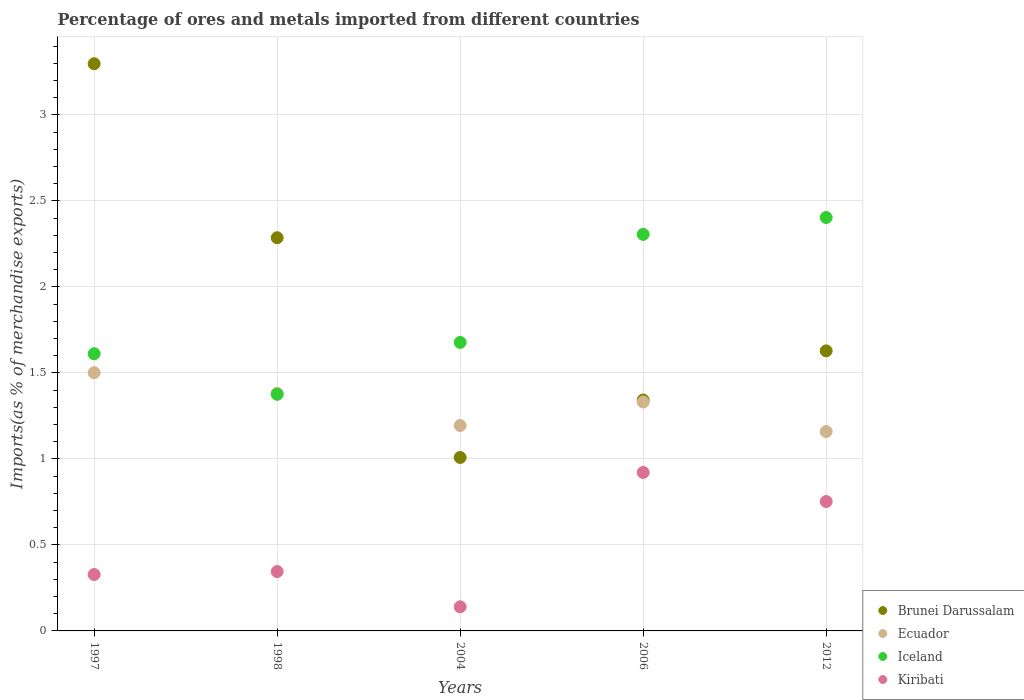How many different coloured dotlines are there?
Keep it short and to the point. 4. What is the percentage of imports to different countries in Brunei Darussalam in 2004?
Your answer should be very brief. 1.01. Across all years, what is the maximum percentage of imports to different countries in Ecuador?
Provide a short and direct response. 1.5. Across all years, what is the minimum percentage of imports to different countries in Kiribati?
Your answer should be very brief. 0.14. What is the total percentage of imports to different countries in Ecuador in the graph?
Ensure brevity in your answer.  6.57. What is the difference between the percentage of imports to different countries in Brunei Darussalam in 1997 and that in 2012?
Offer a terse response. 1.67. What is the difference between the percentage of imports to different countries in Iceland in 2004 and the percentage of imports to different countries in Kiribati in 2012?
Make the answer very short. 0.93. What is the average percentage of imports to different countries in Kiribati per year?
Keep it short and to the point. 0.5. In the year 1998, what is the difference between the percentage of imports to different countries in Ecuador and percentage of imports to different countries in Kiribati?
Provide a short and direct response. 1.04. What is the ratio of the percentage of imports to different countries in Ecuador in 2004 to that in 2012?
Your answer should be very brief. 1.03. What is the difference between the highest and the second highest percentage of imports to different countries in Iceland?
Your response must be concise. 0.1. What is the difference between the highest and the lowest percentage of imports to different countries in Brunei Darussalam?
Your answer should be compact. 2.29. In how many years, is the percentage of imports to different countries in Ecuador greater than the average percentage of imports to different countries in Ecuador taken over all years?
Your answer should be compact. 3. Is it the case that in every year, the sum of the percentage of imports to different countries in Kiribati and percentage of imports to different countries in Ecuador  is greater than the sum of percentage of imports to different countries in Iceland and percentage of imports to different countries in Brunei Darussalam?
Your answer should be compact. Yes. How many dotlines are there?
Provide a short and direct response. 4. Does the graph contain any zero values?
Give a very brief answer. No. Does the graph contain grids?
Keep it short and to the point. Yes. Where does the legend appear in the graph?
Make the answer very short. Bottom right. How many legend labels are there?
Ensure brevity in your answer.  4. How are the legend labels stacked?
Your response must be concise. Vertical. What is the title of the graph?
Provide a short and direct response. Percentage of ores and metals imported from different countries. What is the label or title of the X-axis?
Your answer should be very brief. Years. What is the label or title of the Y-axis?
Offer a terse response. Imports(as % of merchandise exports). What is the Imports(as % of merchandise exports) in Brunei Darussalam in 1997?
Provide a short and direct response. 3.3. What is the Imports(as % of merchandise exports) in Ecuador in 1997?
Offer a terse response. 1.5. What is the Imports(as % of merchandise exports) of Iceland in 1997?
Give a very brief answer. 1.61. What is the Imports(as % of merchandise exports) in Kiribati in 1997?
Ensure brevity in your answer.  0.33. What is the Imports(as % of merchandise exports) of Brunei Darussalam in 1998?
Your response must be concise. 2.29. What is the Imports(as % of merchandise exports) of Ecuador in 1998?
Keep it short and to the point. 1.38. What is the Imports(as % of merchandise exports) in Iceland in 1998?
Your answer should be compact. 1.38. What is the Imports(as % of merchandise exports) of Kiribati in 1998?
Your answer should be compact. 0.35. What is the Imports(as % of merchandise exports) of Brunei Darussalam in 2004?
Make the answer very short. 1.01. What is the Imports(as % of merchandise exports) in Ecuador in 2004?
Offer a very short reply. 1.19. What is the Imports(as % of merchandise exports) in Iceland in 2004?
Ensure brevity in your answer.  1.68. What is the Imports(as % of merchandise exports) in Kiribati in 2004?
Provide a succinct answer. 0.14. What is the Imports(as % of merchandise exports) in Brunei Darussalam in 2006?
Keep it short and to the point. 1.34. What is the Imports(as % of merchandise exports) of Ecuador in 2006?
Your answer should be very brief. 1.33. What is the Imports(as % of merchandise exports) in Iceland in 2006?
Your response must be concise. 2.31. What is the Imports(as % of merchandise exports) of Kiribati in 2006?
Give a very brief answer. 0.92. What is the Imports(as % of merchandise exports) of Brunei Darussalam in 2012?
Make the answer very short. 1.63. What is the Imports(as % of merchandise exports) of Ecuador in 2012?
Your answer should be very brief. 1.16. What is the Imports(as % of merchandise exports) in Iceland in 2012?
Your answer should be very brief. 2.4. What is the Imports(as % of merchandise exports) in Kiribati in 2012?
Ensure brevity in your answer.  0.75. Across all years, what is the maximum Imports(as % of merchandise exports) of Brunei Darussalam?
Provide a short and direct response. 3.3. Across all years, what is the maximum Imports(as % of merchandise exports) of Ecuador?
Your answer should be compact. 1.5. Across all years, what is the maximum Imports(as % of merchandise exports) of Iceland?
Offer a terse response. 2.4. Across all years, what is the maximum Imports(as % of merchandise exports) of Kiribati?
Offer a very short reply. 0.92. Across all years, what is the minimum Imports(as % of merchandise exports) of Brunei Darussalam?
Keep it short and to the point. 1.01. Across all years, what is the minimum Imports(as % of merchandise exports) in Ecuador?
Your answer should be very brief. 1.16. Across all years, what is the minimum Imports(as % of merchandise exports) of Iceland?
Make the answer very short. 1.38. Across all years, what is the minimum Imports(as % of merchandise exports) in Kiribati?
Make the answer very short. 0.14. What is the total Imports(as % of merchandise exports) in Brunei Darussalam in the graph?
Your answer should be compact. 9.56. What is the total Imports(as % of merchandise exports) in Ecuador in the graph?
Give a very brief answer. 6.57. What is the total Imports(as % of merchandise exports) of Iceland in the graph?
Your answer should be very brief. 9.37. What is the total Imports(as % of merchandise exports) in Kiribati in the graph?
Make the answer very short. 2.49. What is the difference between the Imports(as % of merchandise exports) in Brunei Darussalam in 1997 and that in 1998?
Your answer should be very brief. 1.01. What is the difference between the Imports(as % of merchandise exports) in Ecuador in 1997 and that in 1998?
Your answer should be very brief. 0.12. What is the difference between the Imports(as % of merchandise exports) of Iceland in 1997 and that in 1998?
Ensure brevity in your answer.  0.24. What is the difference between the Imports(as % of merchandise exports) of Kiribati in 1997 and that in 1998?
Give a very brief answer. -0.02. What is the difference between the Imports(as % of merchandise exports) in Brunei Darussalam in 1997 and that in 2004?
Keep it short and to the point. 2.29. What is the difference between the Imports(as % of merchandise exports) in Ecuador in 1997 and that in 2004?
Make the answer very short. 0.31. What is the difference between the Imports(as % of merchandise exports) in Iceland in 1997 and that in 2004?
Your answer should be very brief. -0.07. What is the difference between the Imports(as % of merchandise exports) of Kiribati in 1997 and that in 2004?
Give a very brief answer. 0.19. What is the difference between the Imports(as % of merchandise exports) in Brunei Darussalam in 1997 and that in 2006?
Your response must be concise. 1.96. What is the difference between the Imports(as % of merchandise exports) in Ecuador in 1997 and that in 2006?
Offer a terse response. 0.17. What is the difference between the Imports(as % of merchandise exports) in Iceland in 1997 and that in 2006?
Your response must be concise. -0.69. What is the difference between the Imports(as % of merchandise exports) in Kiribati in 1997 and that in 2006?
Make the answer very short. -0.59. What is the difference between the Imports(as % of merchandise exports) of Brunei Darussalam in 1997 and that in 2012?
Keep it short and to the point. 1.67. What is the difference between the Imports(as % of merchandise exports) in Ecuador in 1997 and that in 2012?
Offer a very short reply. 0.34. What is the difference between the Imports(as % of merchandise exports) of Iceland in 1997 and that in 2012?
Your answer should be very brief. -0.79. What is the difference between the Imports(as % of merchandise exports) of Kiribati in 1997 and that in 2012?
Your answer should be compact. -0.42. What is the difference between the Imports(as % of merchandise exports) of Brunei Darussalam in 1998 and that in 2004?
Provide a short and direct response. 1.28. What is the difference between the Imports(as % of merchandise exports) of Ecuador in 1998 and that in 2004?
Make the answer very short. 0.19. What is the difference between the Imports(as % of merchandise exports) in Iceland in 1998 and that in 2004?
Ensure brevity in your answer.  -0.3. What is the difference between the Imports(as % of merchandise exports) in Kiribati in 1998 and that in 2004?
Provide a succinct answer. 0.2. What is the difference between the Imports(as % of merchandise exports) of Brunei Darussalam in 1998 and that in 2006?
Your response must be concise. 0.94. What is the difference between the Imports(as % of merchandise exports) in Ecuador in 1998 and that in 2006?
Ensure brevity in your answer.  0.05. What is the difference between the Imports(as % of merchandise exports) of Iceland in 1998 and that in 2006?
Keep it short and to the point. -0.93. What is the difference between the Imports(as % of merchandise exports) of Kiribati in 1998 and that in 2006?
Give a very brief answer. -0.58. What is the difference between the Imports(as % of merchandise exports) in Brunei Darussalam in 1998 and that in 2012?
Provide a short and direct response. 0.66. What is the difference between the Imports(as % of merchandise exports) of Ecuador in 1998 and that in 2012?
Ensure brevity in your answer.  0.22. What is the difference between the Imports(as % of merchandise exports) of Iceland in 1998 and that in 2012?
Keep it short and to the point. -1.03. What is the difference between the Imports(as % of merchandise exports) in Kiribati in 1998 and that in 2012?
Provide a short and direct response. -0.41. What is the difference between the Imports(as % of merchandise exports) of Brunei Darussalam in 2004 and that in 2006?
Your answer should be compact. -0.33. What is the difference between the Imports(as % of merchandise exports) in Ecuador in 2004 and that in 2006?
Keep it short and to the point. -0.14. What is the difference between the Imports(as % of merchandise exports) of Iceland in 2004 and that in 2006?
Provide a succinct answer. -0.63. What is the difference between the Imports(as % of merchandise exports) of Kiribati in 2004 and that in 2006?
Keep it short and to the point. -0.78. What is the difference between the Imports(as % of merchandise exports) of Brunei Darussalam in 2004 and that in 2012?
Keep it short and to the point. -0.62. What is the difference between the Imports(as % of merchandise exports) of Ecuador in 2004 and that in 2012?
Offer a terse response. 0.03. What is the difference between the Imports(as % of merchandise exports) in Iceland in 2004 and that in 2012?
Offer a very short reply. -0.73. What is the difference between the Imports(as % of merchandise exports) of Kiribati in 2004 and that in 2012?
Offer a very short reply. -0.61. What is the difference between the Imports(as % of merchandise exports) of Brunei Darussalam in 2006 and that in 2012?
Make the answer very short. -0.29. What is the difference between the Imports(as % of merchandise exports) in Ecuador in 2006 and that in 2012?
Your response must be concise. 0.17. What is the difference between the Imports(as % of merchandise exports) of Iceland in 2006 and that in 2012?
Make the answer very short. -0.1. What is the difference between the Imports(as % of merchandise exports) of Kiribati in 2006 and that in 2012?
Offer a terse response. 0.17. What is the difference between the Imports(as % of merchandise exports) in Brunei Darussalam in 1997 and the Imports(as % of merchandise exports) in Ecuador in 1998?
Make the answer very short. 1.92. What is the difference between the Imports(as % of merchandise exports) in Brunei Darussalam in 1997 and the Imports(as % of merchandise exports) in Iceland in 1998?
Offer a very short reply. 1.92. What is the difference between the Imports(as % of merchandise exports) in Brunei Darussalam in 1997 and the Imports(as % of merchandise exports) in Kiribati in 1998?
Ensure brevity in your answer.  2.95. What is the difference between the Imports(as % of merchandise exports) of Ecuador in 1997 and the Imports(as % of merchandise exports) of Iceland in 1998?
Give a very brief answer. 0.13. What is the difference between the Imports(as % of merchandise exports) of Ecuador in 1997 and the Imports(as % of merchandise exports) of Kiribati in 1998?
Your answer should be compact. 1.16. What is the difference between the Imports(as % of merchandise exports) of Iceland in 1997 and the Imports(as % of merchandise exports) of Kiribati in 1998?
Provide a succinct answer. 1.27. What is the difference between the Imports(as % of merchandise exports) of Brunei Darussalam in 1997 and the Imports(as % of merchandise exports) of Ecuador in 2004?
Make the answer very short. 2.1. What is the difference between the Imports(as % of merchandise exports) of Brunei Darussalam in 1997 and the Imports(as % of merchandise exports) of Iceland in 2004?
Ensure brevity in your answer.  1.62. What is the difference between the Imports(as % of merchandise exports) of Brunei Darussalam in 1997 and the Imports(as % of merchandise exports) of Kiribati in 2004?
Make the answer very short. 3.16. What is the difference between the Imports(as % of merchandise exports) of Ecuador in 1997 and the Imports(as % of merchandise exports) of Iceland in 2004?
Make the answer very short. -0.18. What is the difference between the Imports(as % of merchandise exports) of Ecuador in 1997 and the Imports(as % of merchandise exports) of Kiribati in 2004?
Your response must be concise. 1.36. What is the difference between the Imports(as % of merchandise exports) in Iceland in 1997 and the Imports(as % of merchandise exports) in Kiribati in 2004?
Keep it short and to the point. 1.47. What is the difference between the Imports(as % of merchandise exports) in Brunei Darussalam in 1997 and the Imports(as % of merchandise exports) in Ecuador in 2006?
Ensure brevity in your answer.  1.97. What is the difference between the Imports(as % of merchandise exports) of Brunei Darussalam in 1997 and the Imports(as % of merchandise exports) of Iceland in 2006?
Provide a short and direct response. 0.99. What is the difference between the Imports(as % of merchandise exports) in Brunei Darussalam in 1997 and the Imports(as % of merchandise exports) in Kiribati in 2006?
Offer a terse response. 2.38. What is the difference between the Imports(as % of merchandise exports) in Ecuador in 1997 and the Imports(as % of merchandise exports) in Iceland in 2006?
Your answer should be very brief. -0.8. What is the difference between the Imports(as % of merchandise exports) of Ecuador in 1997 and the Imports(as % of merchandise exports) of Kiribati in 2006?
Provide a short and direct response. 0.58. What is the difference between the Imports(as % of merchandise exports) of Iceland in 1997 and the Imports(as % of merchandise exports) of Kiribati in 2006?
Provide a short and direct response. 0.69. What is the difference between the Imports(as % of merchandise exports) of Brunei Darussalam in 1997 and the Imports(as % of merchandise exports) of Ecuador in 2012?
Offer a terse response. 2.14. What is the difference between the Imports(as % of merchandise exports) in Brunei Darussalam in 1997 and the Imports(as % of merchandise exports) in Iceland in 2012?
Provide a short and direct response. 0.89. What is the difference between the Imports(as % of merchandise exports) of Brunei Darussalam in 1997 and the Imports(as % of merchandise exports) of Kiribati in 2012?
Offer a terse response. 2.55. What is the difference between the Imports(as % of merchandise exports) of Ecuador in 1997 and the Imports(as % of merchandise exports) of Iceland in 2012?
Keep it short and to the point. -0.9. What is the difference between the Imports(as % of merchandise exports) of Ecuador in 1997 and the Imports(as % of merchandise exports) of Kiribati in 2012?
Ensure brevity in your answer.  0.75. What is the difference between the Imports(as % of merchandise exports) of Iceland in 1997 and the Imports(as % of merchandise exports) of Kiribati in 2012?
Provide a short and direct response. 0.86. What is the difference between the Imports(as % of merchandise exports) in Brunei Darussalam in 1998 and the Imports(as % of merchandise exports) in Ecuador in 2004?
Your answer should be very brief. 1.09. What is the difference between the Imports(as % of merchandise exports) in Brunei Darussalam in 1998 and the Imports(as % of merchandise exports) in Iceland in 2004?
Give a very brief answer. 0.61. What is the difference between the Imports(as % of merchandise exports) in Brunei Darussalam in 1998 and the Imports(as % of merchandise exports) in Kiribati in 2004?
Provide a succinct answer. 2.15. What is the difference between the Imports(as % of merchandise exports) of Ecuador in 1998 and the Imports(as % of merchandise exports) of Iceland in 2004?
Your answer should be very brief. -0.3. What is the difference between the Imports(as % of merchandise exports) of Ecuador in 1998 and the Imports(as % of merchandise exports) of Kiribati in 2004?
Give a very brief answer. 1.24. What is the difference between the Imports(as % of merchandise exports) of Iceland in 1998 and the Imports(as % of merchandise exports) of Kiribati in 2004?
Your answer should be compact. 1.24. What is the difference between the Imports(as % of merchandise exports) of Brunei Darussalam in 1998 and the Imports(as % of merchandise exports) of Ecuador in 2006?
Your answer should be compact. 0.96. What is the difference between the Imports(as % of merchandise exports) of Brunei Darussalam in 1998 and the Imports(as % of merchandise exports) of Iceland in 2006?
Keep it short and to the point. -0.02. What is the difference between the Imports(as % of merchandise exports) of Brunei Darussalam in 1998 and the Imports(as % of merchandise exports) of Kiribati in 2006?
Give a very brief answer. 1.36. What is the difference between the Imports(as % of merchandise exports) in Ecuador in 1998 and the Imports(as % of merchandise exports) in Iceland in 2006?
Provide a short and direct response. -0.92. What is the difference between the Imports(as % of merchandise exports) of Ecuador in 1998 and the Imports(as % of merchandise exports) of Kiribati in 2006?
Offer a terse response. 0.46. What is the difference between the Imports(as % of merchandise exports) in Iceland in 1998 and the Imports(as % of merchandise exports) in Kiribati in 2006?
Keep it short and to the point. 0.45. What is the difference between the Imports(as % of merchandise exports) of Brunei Darussalam in 1998 and the Imports(as % of merchandise exports) of Ecuador in 2012?
Ensure brevity in your answer.  1.13. What is the difference between the Imports(as % of merchandise exports) of Brunei Darussalam in 1998 and the Imports(as % of merchandise exports) of Iceland in 2012?
Provide a short and direct response. -0.12. What is the difference between the Imports(as % of merchandise exports) of Brunei Darussalam in 1998 and the Imports(as % of merchandise exports) of Kiribati in 2012?
Your answer should be compact. 1.53. What is the difference between the Imports(as % of merchandise exports) of Ecuador in 1998 and the Imports(as % of merchandise exports) of Iceland in 2012?
Make the answer very short. -1.02. What is the difference between the Imports(as % of merchandise exports) in Ecuador in 1998 and the Imports(as % of merchandise exports) in Kiribati in 2012?
Your answer should be compact. 0.63. What is the difference between the Imports(as % of merchandise exports) in Iceland in 1998 and the Imports(as % of merchandise exports) in Kiribati in 2012?
Ensure brevity in your answer.  0.62. What is the difference between the Imports(as % of merchandise exports) in Brunei Darussalam in 2004 and the Imports(as % of merchandise exports) in Ecuador in 2006?
Keep it short and to the point. -0.32. What is the difference between the Imports(as % of merchandise exports) in Brunei Darussalam in 2004 and the Imports(as % of merchandise exports) in Iceland in 2006?
Offer a terse response. -1.3. What is the difference between the Imports(as % of merchandise exports) in Brunei Darussalam in 2004 and the Imports(as % of merchandise exports) in Kiribati in 2006?
Keep it short and to the point. 0.09. What is the difference between the Imports(as % of merchandise exports) in Ecuador in 2004 and the Imports(as % of merchandise exports) in Iceland in 2006?
Provide a short and direct response. -1.11. What is the difference between the Imports(as % of merchandise exports) in Ecuador in 2004 and the Imports(as % of merchandise exports) in Kiribati in 2006?
Make the answer very short. 0.27. What is the difference between the Imports(as % of merchandise exports) of Iceland in 2004 and the Imports(as % of merchandise exports) of Kiribati in 2006?
Give a very brief answer. 0.76. What is the difference between the Imports(as % of merchandise exports) in Brunei Darussalam in 2004 and the Imports(as % of merchandise exports) in Ecuador in 2012?
Your response must be concise. -0.15. What is the difference between the Imports(as % of merchandise exports) of Brunei Darussalam in 2004 and the Imports(as % of merchandise exports) of Iceland in 2012?
Provide a short and direct response. -1.4. What is the difference between the Imports(as % of merchandise exports) of Brunei Darussalam in 2004 and the Imports(as % of merchandise exports) of Kiribati in 2012?
Provide a succinct answer. 0.26. What is the difference between the Imports(as % of merchandise exports) of Ecuador in 2004 and the Imports(as % of merchandise exports) of Iceland in 2012?
Your answer should be compact. -1.21. What is the difference between the Imports(as % of merchandise exports) of Ecuador in 2004 and the Imports(as % of merchandise exports) of Kiribati in 2012?
Your response must be concise. 0.44. What is the difference between the Imports(as % of merchandise exports) in Iceland in 2004 and the Imports(as % of merchandise exports) in Kiribati in 2012?
Provide a succinct answer. 0.93. What is the difference between the Imports(as % of merchandise exports) of Brunei Darussalam in 2006 and the Imports(as % of merchandise exports) of Ecuador in 2012?
Ensure brevity in your answer.  0.18. What is the difference between the Imports(as % of merchandise exports) in Brunei Darussalam in 2006 and the Imports(as % of merchandise exports) in Iceland in 2012?
Your answer should be compact. -1.06. What is the difference between the Imports(as % of merchandise exports) in Brunei Darussalam in 2006 and the Imports(as % of merchandise exports) in Kiribati in 2012?
Your answer should be very brief. 0.59. What is the difference between the Imports(as % of merchandise exports) of Ecuador in 2006 and the Imports(as % of merchandise exports) of Iceland in 2012?
Your answer should be compact. -1.07. What is the difference between the Imports(as % of merchandise exports) in Ecuador in 2006 and the Imports(as % of merchandise exports) in Kiribati in 2012?
Give a very brief answer. 0.58. What is the difference between the Imports(as % of merchandise exports) of Iceland in 2006 and the Imports(as % of merchandise exports) of Kiribati in 2012?
Make the answer very short. 1.55. What is the average Imports(as % of merchandise exports) in Brunei Darussalam per year?
Offer a very short reply. 1.91. What is the average Imports(as % of merchandise exports) of Ecuador per year?
Provide a succinct answer. 1.31. What is the average Imports(as % of merchandise exports) in Iceland per year?
Offer a terse response. 1.87. What is the average Imports(as % of merchandise exports) in Kiribati per year?
Make the answer very short. 0.5. In the year 1997, what is the difference between the Imports(as % of merchandise exports) of Brunei Darussalam and Imports(as % of merchandise exports) of Ecuador?
Provide a short and direct response. 1.8. In the year 1997, what is the difference between the Imports(as % of merchandise exports) in Brunei Darussalam and Imports(as % of merchandise exports) in Iceland?
Make the answer very short. 1.69. In the year 1997, what is the difference between the Imports(as % of merchandise exports) of Brunei Darussalam and Imports(as % of merchandise exports) of Kiribati?
Ensure brevity in your answer.  2.97. In the year 1997, what is the difference between the Imports(as % of merchandise exports) of Ecuador and Imports(as % of merchandise exports) of Iceland?
Provide a short and direct response. -0.11. In the year 1997, what is the difference between the Imports(as % of merchandise exports) of Ecuador and Imports(as % of merchandise exports) of Kiribati?
Ensure brevity in your answer.  1.17. In the year 1997, what is the difference between the Imports(as % of merchandise exports) in Iceland and Imports(as % of merchandise exports) in Kiribati?
Provide a short and direct response. 1.28. In the year 1998, what is the difference between the Imports(as % of merchandise exports) in Brunei Darussalam and Imports(as % of merchandise exports) in Ecuador?
Provide a short and direct response. 0.9. In the year 1998, what is the difference between the Imports(as % of merchandise exports) of Brunei Darussalam and Imports(as % of merchandise exports) of Iceland?
Your answer should be compact. 0.91. In the year 1998, what is the difference between the Imports(as % of merchandise exports) in Brunei Darussalam and Imports(as % of merchandise exports) in Kiribati?
Keep it short and to the point. 1.94. In the year 1998, what is the difference between the Imports(as % of merchandise exports) in Ecuador and Imports(as % of merchandise exports) in Iceland?
Provide a short and direct response. 0.01. In the year 1998, what is the difference between the Imports(as % of merchandise exports) in Ecuador and Imports(as % of merchandise exports) in Kiribati?
Provide a short and direct response. 1.04. In the year 1998, what is the difference between the Imports(as % of merchandise exports) in Iceland and Imports(as % of merchandise exports) in Kiribati?
Ensure brevity in your answer.  1.03. In the year 2004, what is the difference between the Imports(as % of merchandise exports) in Brunei Darussalam and Imports(as % of merchandise exports) in Ecuador?
Provide a short and direct response. -0.19. In the year 2004, what is the difference between the Imports(as % of merchandise exports) in Brunei Darussalam and Imports(as % of merchandise exports) in Iceland?
Keep it short and to the point. -0.67. In the year 2004, what is the difference between the Imports(as % of merchandise exports) in Brunei Darussalam and Imports(as % of merchandise exports) in Kiribati?
Your response must be concise. 0.87. In the year 2004, what is the difference between the Imports(as % of merchandise exports) of Ecuador and Imports(as % of merchandise exports) of Iceland?
Keep it short and to the point. -0.48. In the year 2004, what is the difference between the Imports(as % of merchandise exports) of Ecuador and Imports(as % of merchandise exports) of Kiribati?
Your answer should be very brief. 1.05. In the year 2004, what is the difference between the Imports(as % of merchandise exports) in Iceland and Imports(as % of merchandise exports) in Kiribati?
Your response must be concise. 1.54. In the year 2006, what is the difference between the Imports(as % of merchandise exports) in Brunei Darussalam and Imports(as % of merchandise exports) in Ecuador?
Provide a short and direct response. 0.01. In the year 2006, what is the difference between the Imports(as % of merchandise exports) in Brunei Darussalam and Imports(as % of merchandise exports) in Iceland?
Give a very brief answer. -0.96. In the year 2006, what is the difference between the Imports(as % of merchandise exports) of Brunei Darussalam and Imports(as % of merchandise exports) of Kiribati?
Ensure brevity in your answer.  0.42. In the year 2006, what is the difference between the Imports(as % of merchandise exports) of Ecuador and Imports(as % of merchandise exports) of Iceland?
Offer a terse response. -0.97. In the year 2006, what is the difference between the Imports(as % of merchandise exports) of Ecuador and Imports(as % of merchandise exports) of Kiribati?
Offer a terse response. 0.41. In the year 2006, what is the difference between the Imports(as % of merchandise exports) of Iceland and Imports(as % of merchandise exports) of Kiribati?
Provide a succinct answer. 1.38. In the year 2012, what is the difference between the Imports(as % of merchandise exports) of Brunei Darussalam and Imports(as % of merchandise exports) of Ecuador?
Your answer should be compact. 0.47. In the year 2012, what is the difference between the Imports(as % of merchandise exports) in Brunei Darussalam and Imports(as % of merchandise exports) in Iceland?
Your response must be concise. -0.78. In the year 2012, what is the difference between the Imports(as % of merchandise exports) in Brunei Darussalam and Imports(as % of merchandise exports) in Kiribati?
Offer a terse response. 0.88. In the year 2012, what is the difference between the Imports(as % of merchandise exports) in Ecuador and Imports(as % of merchandise exports) in Iceland?
Make the answer very short. -1.24. In the year 2012, what is the difference between the Imports(as % of merchandise exports) of Ecuador and Imports(as % of merchandise exports) of Kiribati?
Offer a terse response. 0.41. In the year 2012, what is the difference between the Imports(as % of merchandise exports) of Iceland and Imports(as % of merchandise exports) of Kiribati?
Make the answer very short. 1.65. What is the ratio of the Imports(as % of merchandise exports) in Brunei Darussalam in 1997 to that in 1998?
Your response must be concise. 1.44. What is the ratio of the Imports(as % of merchandise exports) in Ecuador in 1997 to that in 1998?
Provide a succinct answer. 1.09. What is the ratio of the Imports(as % of merchandise exports) in Iceland in 1997 to that in 1998?
Provide a succinct answer. 1.17. What is the ratio of the Imports(as % of merchandise exports) in Kiribati in 1997 to that in 1998?
Provide a succinct answer. 0.95. What is the ratio of the Imports(as % of merchandise exports) of Brunei Darussalam in 1997 to that in 2004?
Your answer should be compact. 3.27. What is the ratio of the Imports(as % of merchandise exports) in Ecuador in 1997 to that in 2004?
Provide a short and direct response. 1.26. What is the ratio of the Imports(as % of merchandise exports) of Iceland in 1997 to that in 2004?
Give a very brief answer. 0.96. What is the ratio of the Imports(as % of merchandise exports) of Kiribati in 1997 to that in 2004?
Make the answer very short. 2.34. What is the ratio of the Imports(as % of merchandise exports) of Brunei Darussalam in 1997 to that in 2006?
Make the answer very short. 2.46. What is the ratio of the Imports(as % of merchandise exports) of Ecuador in 1997 to that in 2006?
Ensure brevity in your answer.  1.13. What is the ratio of the Imports(as % of merchandise exports) in Iceland in 1997 to that in 2006?
Ensure brevity in your answer.  0.7. What is the ratio of the Imports(as % of merchandise exports) in Kiribati in 1997 to that in 2006?
Make the answer very short. 0.36. What is the ratio of the Imports(as % of merchandise exports) of Brunei Darussalam in 1997 to that in 2012?
Give a very brief answer. 2.03. What is the ratio of the Imports(as % of merchandise exports) in Ecuador in 1997 to that in 2012?
Provide a succinct answer. 1.3. What is the ratio of the Imports(as % of merchandise exports) of Iceland in 1997 to that in 2012?
Your answer should be compact. 0.67. What is the ratio of the Imports(as % of merchandise exports) of Kiribati in 1997 to that in 2012?
Provide a succinct answer. 0.44. What is the ratio of the Imports(as % of merchandise exports) of Brunei Darussalam in 1998 to that in 2004?
Your answer should be very brief. 2.27. What is the ratio of the Imports(as % of merchandise exports) of Ecuador in 1998 to that in 2004?
Your answer should be compact. 1.16. What is the ratio of the Imports(as % of merchandise exports) of Iceland in 1998 to that in 2004?
Keep it short and to the point. 0.82. What is the ratio of the Imports(as % of merchandise exports) of Kiribati in 1998 to that in 2004?
Offer a terse response. 2.46. What is the ratio of the Imports(as % of merchandise exports) in Brunei Darussalam in 1998 to that in 2006?
Give a very brief answer. 1.7. What is the ratio of the Imports(as % of merchandise exports) in Ecuador in 1998 to that in 2006?
Keep it short and to the point. 1.04. What is the ratio of the Imports(as % of merchandise exports) of Iceland in 1998 to that in 2006?
Keep it short and to the point. 0.6. What is the ratio of the Imports(as % of merchandise exports) in Kiribati in 1998 to that in 2006?
Your answer should be compact. 0.37. What is the ratio of the Imports(as % of merchandise exports) in Brunei Darussalam in 1998 to that in 2012?
Your answer should be compact. 1.4. What is the ratio of the Imports(as % of merchandise exports) in Ecuador in 1998 to that in 2012?
Ensure brevity in your answer.  1.19. What is the ratio of the Imports(as % of merchandise exports) of Iceland in 1998 to that in 2012?
Keep it short and to the point. 0.57. What is the ratio of the Imports(as % of merchandise exports) in Kiribati in 1998 to that in 2012?
Keep it short and to the point. 0.46. What is the ratio of the Imports(as % of merchandise exports) in Brunei Darussalam in 2004 to that in 2006?
Your response must be concise. 0.75. What is the ratio of the Imports(as % of merchandise exports) of Ecuador in 2004 to that in 2006?
Provide a short and direct response. 0.9. What is the ratio of the Imports(as % of merchandise exports) of Iceland in 2004 to that in 2006?
Your response must be concise. 0.73. What is the ratio of the Imports(as % of merchandise exports) in Kiribati in 2004 to that in 2006?
Give a very brief answer. 0.15. What is the ratio of the Imports(as % of merchandise exports) of Brunei Darussalam in 2004 to that in 2012?
Ensure brevity in your answer.  0.62. What is the ratio of the Imports(as % of merchandise exports) of Ecuador in 2004 to that in 2012?
Provide a short and direct response. 1.03. What is the ratio of the Imports(as % of merchandise exports) of Iceland in 2004 to that in 2012?
Offer a very short reply. 0.7. What is the ratio of the Imports(as % of merchandise exports) in Kiribati in 2004 to that in 2012?
Your answer should be very brief. 0.19. What is the ratio of the Imports(as % of merchandise exports) of Brunei Darussalam in 2006 to that in 2012?
Keep it short and to the point. 0.82. What is the ratio of the Imports(as % of merchandise exports) of Ecuador in 2006 to that in 2012?
Your answer should be very brief. 1.15. What is the ratio of the Imports(as % of merchandise exports) of Iceland in 2006 to that in 2012?
Offer a very short reply. 0.96. What is the ratio of the Imports(as % of merchandise exports) of Kiribati in 2006 to that in 2012?
Make the answer very short. 1.22. What is the difference between the highest and the second highest Imports(as % of merchandise exports) of Brunei Darussalam?
Make the answer very short. 1.01. What is the difference between the highest and the second highest Imports(as % of merchandise exports) of Ecuador?
Ensure brevity in your answer.  0.12. What is the difference between the highest and the second highest Imports(as % of merchandise exports) of Iceland?
Your answer should be very brief. 0.1. What is the difference between the highest and the second highest Imports(as % of merchandise exports) in Kiribati?
Offer a very short reply. 0.17. What is the difference between the highest and the lowest Imports(as % of merchandise exports) of Brunei Darussalam?
Provide a succinct answer. 2.29. What is the difference between the highest and the lowest Imports(as % of merchandise exports) in Ecuador?
Offer a very short reply. 0.34. What is the difference between the highest and the lowest Imports(as % of merchandise exports) of Iceland?
Offer a terse response. 1.03. What is the difference between the highest and the lowest Imports(as % of merchandise exports) of Kiribati?
Make the answer very short. 0.78. 